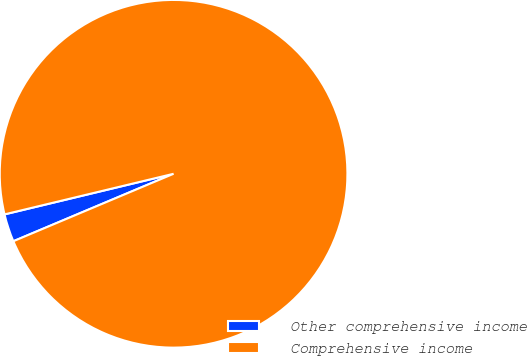<chart> <loc_0><loc_0><loc_500><loc_500><pie_chart><fcel>Other comprehensive income<fcel>Comprehensive income<nl><fcel>2.59%<fcel>97.41%<nl></chart> 